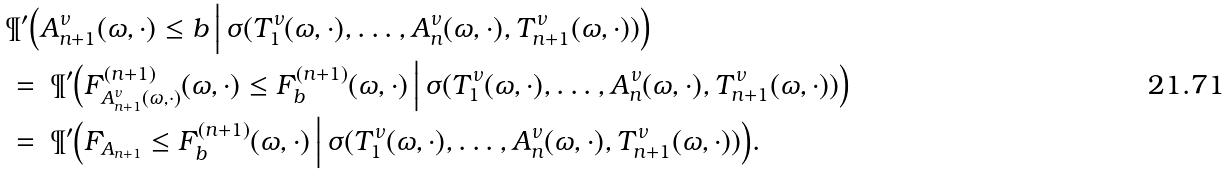<formula> <loc_0><loc_0><loc_500><loc_500>& \P ^ { \prime } \Big ( A _ { n + 1 } ^ { \nu } ( \omega , \cdot ) \leq b \, \Big | \, \sigma ( T _ { 1 } ^ { \nu } ( \omega , \cdot ) , \dots , A _ { n } ^ { \nu } ( \omega , \cdot ) , T _ { n + 1 } ^ { \nu } ( \omega , \cdot ) ) \Big ) \\ & = \ \P ^ { \prime } \Big ( F _ { A _ { n + 1 } ^ { \nu } ( \omega , \cdot ) } ^ { ( n + 1 ) } ( \omega , \cdot ) \leq F _ { b } ^ { ( n + 1 ) } ( \omega , \cdot ) \, \Big | \, \sigma ( T _ { 1 } ^ { \nu } ( \omega , \cdot ) , \dots , A _ { n } ^ { \nu } ( \omega , \cdot ) , T _ { n + 1 } ^ { \nu } ( \omega , \cdot ) ) \Big ) \\ & = \ \P ^ { \prime } \Big ( F _ { A _ { n + 1 } } \leq F _ { b } ^ { ( n + 1 ) } ( \omega , \cdot ) \, \Big | \, \sigma ( T _ { 1 } ^ { \nu } ( \omega , \cdot ) , \dots , A _ { n } ^ { \nu } ( \omega , \cdot ) , T _ { n + 1 } ^ { \nu } ( \omega , \cdot ) ) \Big ) .</formula> 